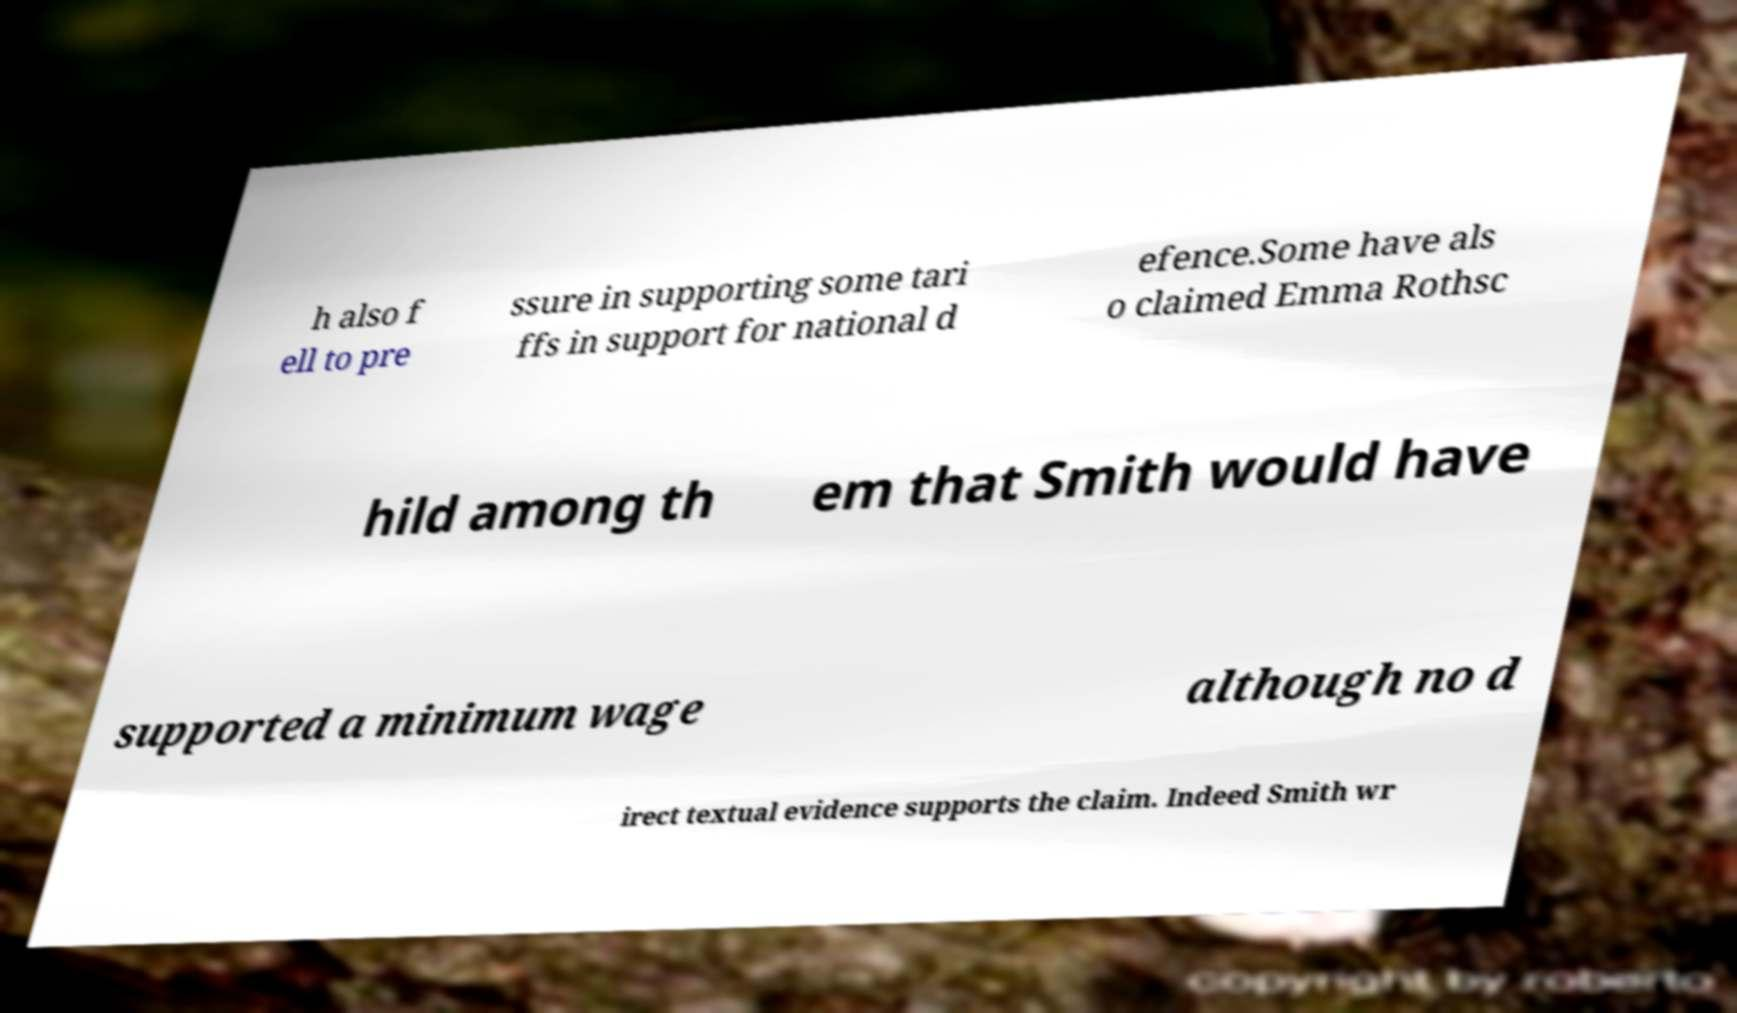What messages or text are displayed in this image? I need them in a readable, typed format. h also f ell to pre ssure in supporting some tari ffs in support for national d efence.Some have als o claimed Emma Rothsc hild among th em that Smith would have supported a minimum wage although no d irect textual evidence supports the claim. Indeed Smith wr 